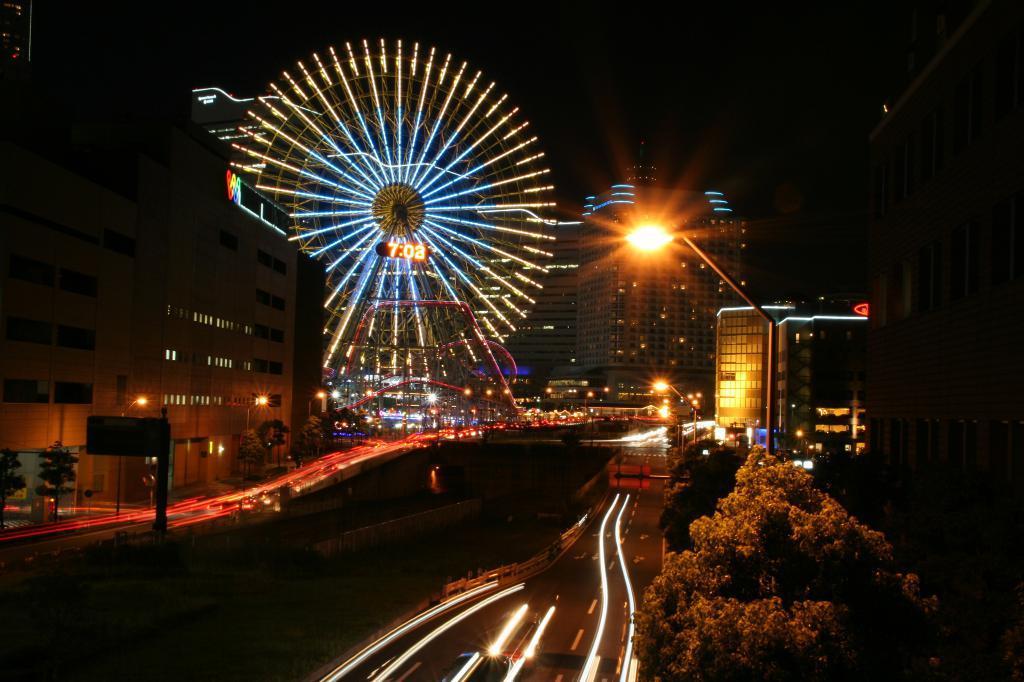In one or two sentences, can you explain what this image depicts? In this image we can see giant-wheel, digital clock, light poles, board, trees and buildings. 